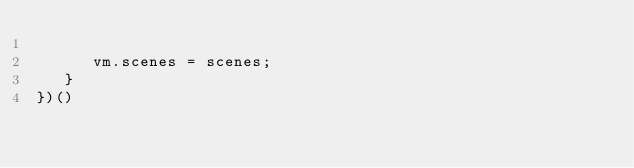Convert code to text. <code><loc_0><loc_0><loc_500><loc_500><_JavaScript_>
      vm.scenes = scenes;
   }
})()
</code> 